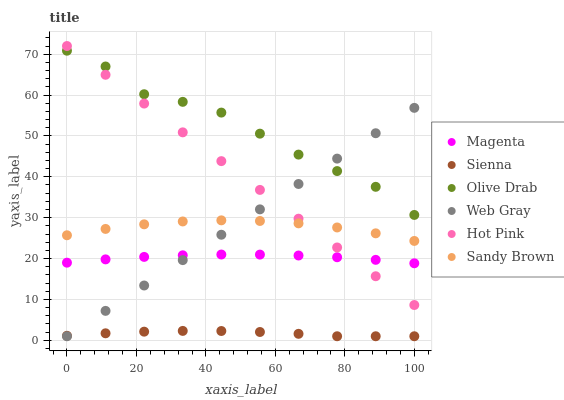Does Sienna have the minimum area under the curve?
Answer yes or no. Yes. Does Olive Drab have the maximum area under the curve?
Answer yes or no. Yes. Does Hot Pink have the minimum area under the curve?
Answer yes or no. No. Does Hot Pink have the maximum area under the curve?
Answer yes or no. No. Is Web Gray the smoothest?
Answer yes or no. Yes. Is Olive Drab the roughest?
Answer yes or no. Yes. Is Hot Pink the smoothest?
Answer yes or no. No. Is Hot Pink the roughest?
Answer yes or no. No. Does Web Gray have the lowest value?
Answer yes or no. Yes. Does Hot Pink have the lowest value?
Answer yes or no. No. Does Hot Pink have the highest value?
Answer yes or no. Yes. Does Sienna have the highest value?
Answer yes or no. No. Is Sienna less than Hot Pink?
Answer yes or no. Yes. Is Olive Drab greater than Sienna?
Answer yes or no. Yes. Does Web Gray intersect Hot Pink?
Answer yes or no. Yes. Is Web Gray less than Hot Pink?
Answer yes or no. No. Is Web Gray greater than Hot Pink?
Answer yes or no. No. Does Sienna intersect Hot Pink?
Answer yes or no. No. 